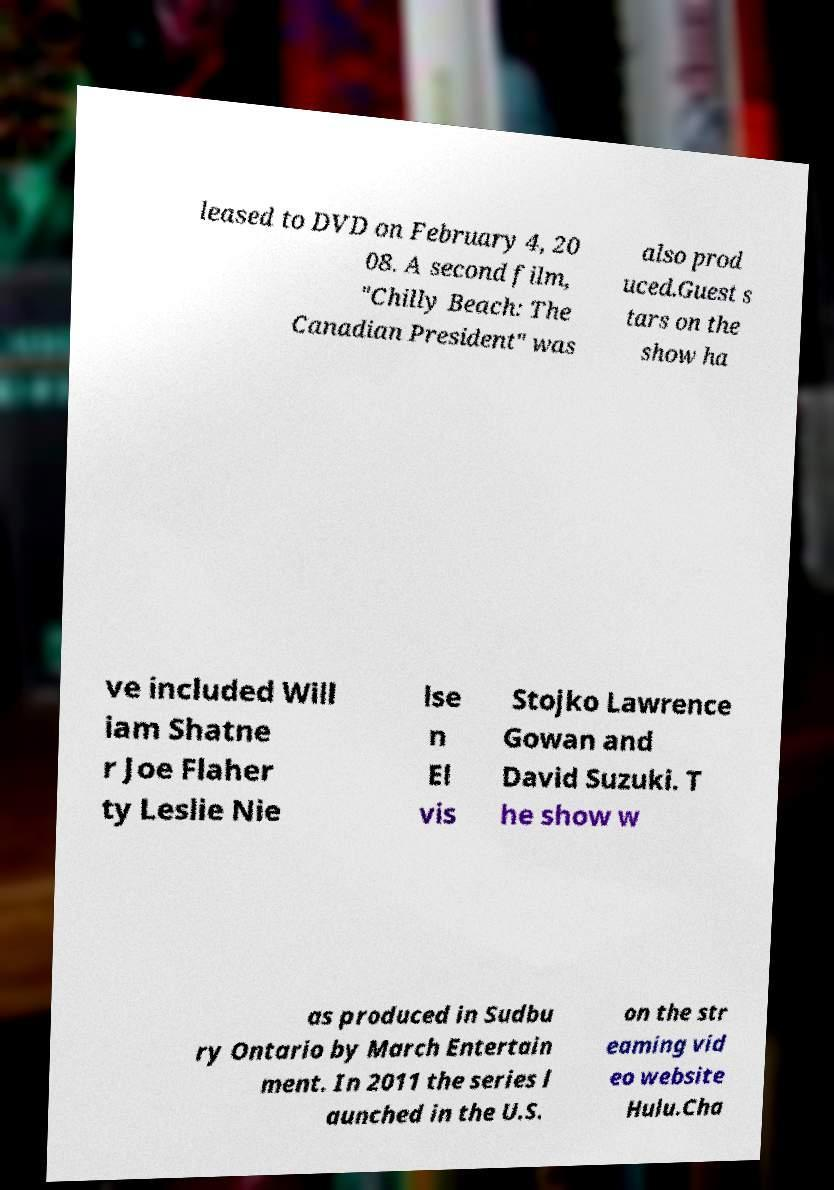Could you assist in decoding the text presented in this image and type it out clearly? leased to DVD on February 4, 20 08. A second film, "Chilly Beach: The Canadian President" was also prod uced.Guest s tars on the show ha ve included Will iam Shatne r Joe Flaher ty Leslie Nie lse n El vis Stojko Lawrence Gowan and David Suzuki. T he show w as produced in Sudbu ry Ontario by March Entertain ment. In 2011 the series l aunched in the U.S. on the str eaming vid eo website Hulu.Cha 